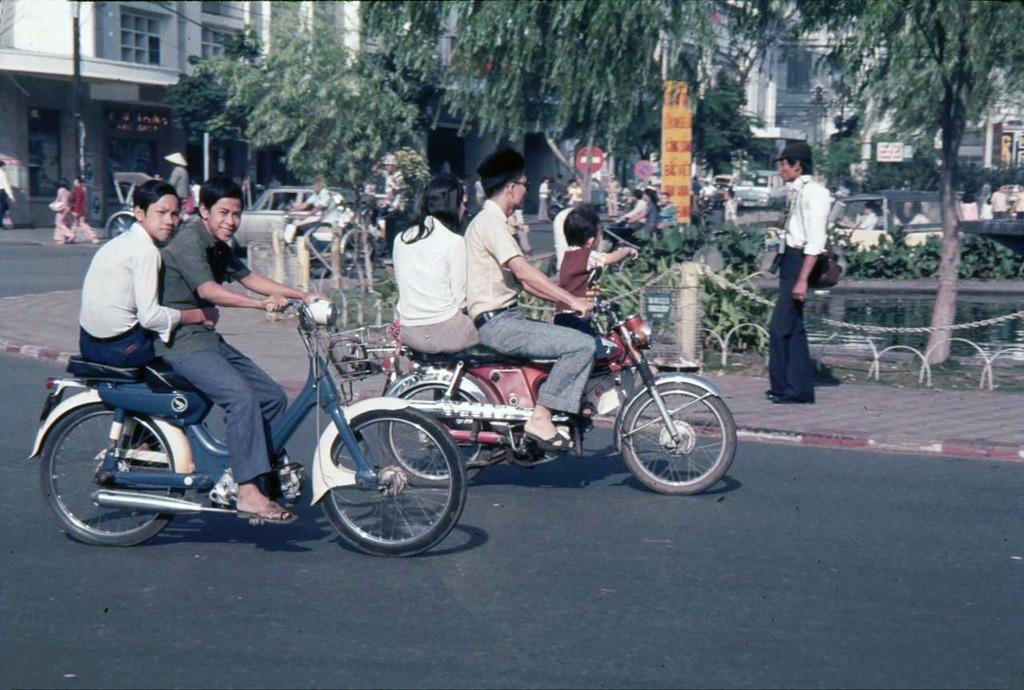Please provide a concise description of this image. In this picture we can see some people on the motor vehicle and on the foot path there is a person and also some trees and buildings around them. 